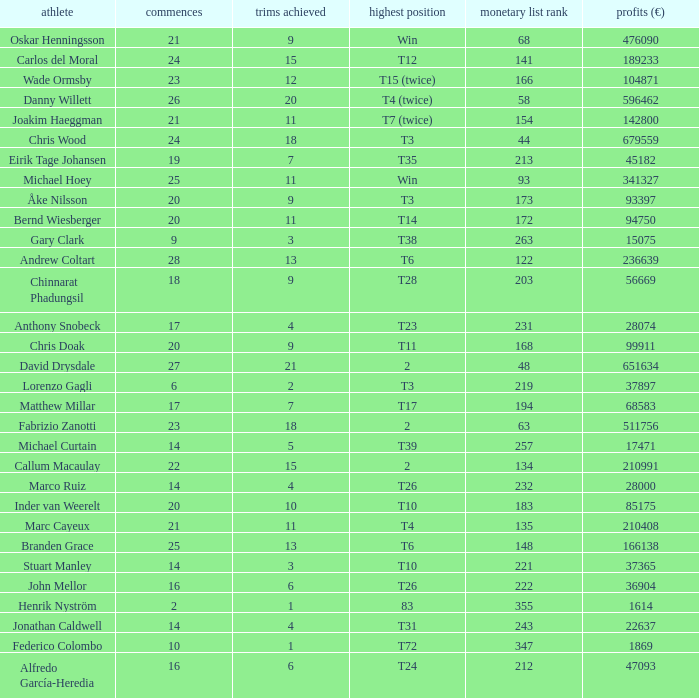How many cuts did Bernd Wiesberger make? 11.0. 